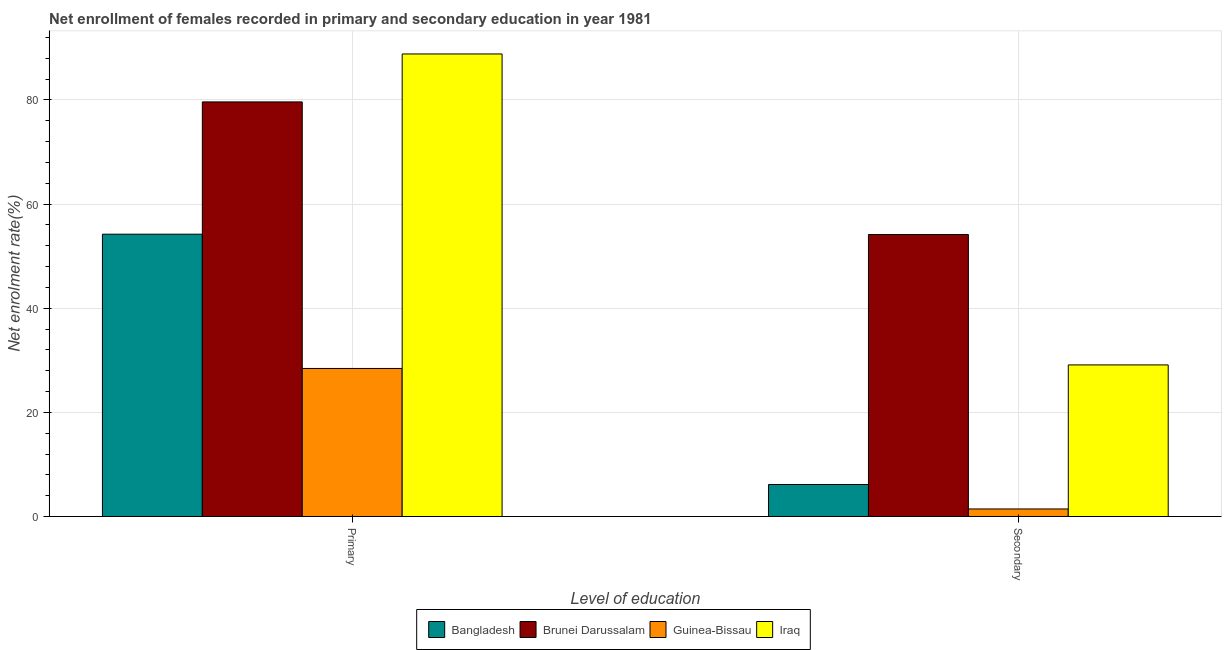How many groups of bars are there?
Provide a succinct answer. 2. Are the number of bars per tick equal to the number of legend labels?
Your response must be concise. Yes. Are the number of bars on each tick of the X-axis equal?
Your answer should be compact. Yes. How many bars are there on the 2nd tick from the left?
Provide a succinct answer. 4. What is the label of the 1st group of bars from the left?
Offer a very short reply. Primary. What is the enrollment rate in primary education in Guinea-Bissau?
Your answer should be compact. 28.43. Across all countries, what is the maximum enrollment rate in primary education?
Your answer should be very brief. 88.82. Across all countries, what is the minimum enrollment rate in secondary education?
Your response must be concise. 1.45. In which country was the enrollment rate in secondary education maximum?
Your answer should be compact. Brunei Darussalam. In which country was the enrollment rate in secondary education minimum?
Give a very brief answer. Guinea-Bissau. What is the total enrollment rate in secondary education in the graph?
Your answer should be very brief. 90.86. What is the difference between the enrollment rate in secondary education in Bangladesh and that in Guinea-Bissau?
Provide a succinct answer. 4.7. What is the difference between the enrollment rate in secondary education in Bangladesh and the enrollment rate in primary education in Iraq?
Your answer should be very brief. -82.67. What is the average enrollment rate in primary education per country?
Provide a succinct answer. 62.77. What is the difference between the enrollment rate in secondary education and enrollment rate in primary education in Bangladesh?
Provide a succinct answer. -48.06. What is the ratio of the enrollment rate in secondary education in Guinea-Bissau to that in Brunei Darussalam?
Offer a very short reply. 0.03. Is the enrollment rate in primary education in Iraq less than that in Guinea-Bissau?
Keep it short and to the point. No. In how many countries, is the enrollment rate in primary education greater than the average enrollment rate in primary education taken over all countries?
Keep it short and to the point. 2. What does the 1st bar from the right in Secondary represents?
Give a very brief answer. Iraq. How many bars are there?
Provide a short and direct response. 8. Are all the bars in the graph horizontal?
Offer a very short reply. No. What is the difference between two consecutive major ticks on the Y-axis?
Offer a very short reply. 20. Are the values on the major ticks of Y-axis written in scientific E-notation?
Make the answer very short. No. Does the graph contain any zero values?
Offer a very short reply. No. Where does the legend appear in the graph?
Offer a very short reply. Bottom center. How many legend labels are there?
Keep it short and to the point. 4. How are the legend labels stacked?
Your response must be concise. Horizontal. What is the title of the graph?
Make the answer very short. Net enrollment of females recorded in primary and secondary education in year 1981. What is the label or title of the X-axis?
Provide a short and direct response. Level of education. What is the label or title of the Y-axis?
Keep it short and to the point. Net enrolment rate(%). What is the Net enrolment rate(%) in Bangladesh in Primary?
Your answer should be compact. 54.21. What is the Net enrolment rate(%) of Brunei Darussalam in Primary?
Provide a short and direct response. 79.61. What is the Net enrolment rate(%) of Guinea-Bissau in Primary?
Provide a succinct answer. 28.43. What is the Net enrolment rate(%) in Iraq in Primary?
Your response must be concise. 88.82. What is the Net enrolment rate(%) in Bangladesh in Secondary?
Provide a short and direct response. 6.15. What is the Net enrolment rate(%) in Brunei Darussalam in Secondary?
Your answer should be compact. 54.15. What is the Net enrolment rate(%) in Guinea-Bissau in Secondary?
Your answer should be compact. 1.45. What is the Net enrolment rate(%) in Iraq in Secondary?
Your answer should be very brief. 29.11. Across all Level of education, what is the maximum Net enrolment rate(%) in Bangladesh?
Make the answer very short. 54.21. Across all Level of education, what is the maximum Net enrolment rate(%) in Brunei Darussalam?
Your response must be concise. 79.61. Across all Level of education, what is the maximum Net enrolment rate(%) in Guinea-Bissau?
Provide a short and direct response. 28.43. Across all Level of education, what is the maximum Net enrolment rate(%) of Iraq?
Your answer should be very brief. 88.82. Across all Level of education, what is the minimum Net enrolment rate(%) in Bangladesh?
Keep it short and to the point. 6.15. Across all Level of education, what is the minimum Net enrolment rate(%) in Brunei Darussalam?
Offer a terse response. 54.15. Across all Level of education, what is the minimum Net enrolment rate(%) of Guinea-Bissau?
Make the answer very short. 1.45. Across all Level of education, what is the minimum Net enrolment rate(%) in Iraq?
Give a very brief answer. 29.11. What is the total Net enrolment rate(%) of Bangladesh in the graph?
Make the answer very short. 60.36. What is the total Net enrolment rate(%) in Brunei Darussalam in the graph?
Offer a very short reply. 133.76. What is the total Net enrolment rate(%) in Guinea-Bissau in the graph?
Your answer should be compact. 29.88. What is the total Net enrolment rate(%) of Iraq in the graph?
Offer a very short reply. 117.93. What is the difference between the Net enrolment rate(%) of Bangladesh in Primary and that in Secondary?
Provide a short and direct response. 48.06. What is the difference between the Net enrolment rate(%) of Brunei Darussalam in Primary and that in Secondary?
Your answer should be compact. 25.46. What is the difference between the Net enrolment rate(%) in Guinea-Bissau in Primary and that in Secondary?
Keep it short and to the point. 26.98. What is the difference between the Net enrolment rate(%) of Iraq in Primary and that in Secondary?
Offer a terse response. 59.71. What is the difference between the Net enrolment rate(%) in Bangladesh in Primary and the Net enrolment rate(%) in Brunei Darussalam in Secondary?
Your response must be concise. 0.06. What is the difference between the Net enrolment rate(%) of Bangladesh in Primary and the Net enrolment rate(%) of Guinea-Bissau in Secondary?
Your answer should be very brief. 52.76. What is the difference between the Net enrolment rate(%) of Bangladesh in Primary and the Net enrolment rate(%) of Iraq in Secondary?
Provide a short and direct response. 25.1. What is the difference between the Net enrolment rate(%) in Brunei Darussalam in Primary and the Net enrolment rate(%) in Guinea-Bissau in Secondary?
Ensure brevity in your answer.  78.16. What is the difference between the Net enrolment rate(%) in Brunei Darussalam in Primary and the Net enrolment rate(%) in Iraq in Secondary?
Offer a terse response. 50.5. What is the difference between the Net enrolment rate(%) of Guinea-Bissau in Primary and the Net enrolment rate(%) of Iraq in Secondary?
Give a very brief answer. -0.68. What is the average Net enrolment rate(%) of Bangladesh per Level of education?
Provide a short and direct response. 30.18. What is the average Net enrolment rate(%) of Brunei Darussalam per Level of education?
Provide a succinct answer. 66.88. What is the average Net enrolment rate(%) of Guinea-Bissau per Level of education?
Provide a short and direct response. 14.94. What is the average Net enrolment rate(%) in Iraq per Level of education?
Keep it short and to the point. 58.97. What is the difference between the Net enrolment rate(%) in Bangladesh and Net enrolment rate(%) in Brunei Darussalam in Primary?
Offer a very short reply. -25.4. What is the difference between the Net enrolment rate(%) in Bangladesh and Net enrolment rate(%) in Guinea-Bissau in Primary?
Provide a succinct answer. 25.78. What is the difference between the Net enrolment rate(%) in Bangladesh and Net enrolment rate(%) in Iraq in Primary?
Your response must be concise. -34.61. What is the difference between the Net enrolment rate(%) in Brunei Darussalam and Net enrolment rate(%) in Guinea-Bissau in Primary?
Your response must be concise. 51.18. What is the difference between the Net enrolment rate(%) of Brunei Darussalam and Net enrolment rate(%) of Iraq in Primary?
Your answer should be very brief. -9.21. What is the difference between the Net enrolment rate(%) of Guinea-Bissau and Net enrolment rate(%) of Iraq in Primary?
Your answer should be very brief. -60.39. What is the difference between the Net enrolment rate(%) of Bangladesh and Net enrolment rate(%) of Brunei Darussalam in Secondary?
Give a very brief answer. -48. What is the difference between the Net enrolment rate(%) of Bangladesh and Net enrolment rate(%) of Guinea-Bissau in Secondary?
Offer a terse response. 4.7. What is the difference between the Net enrolment rate(%) in Bangladesh and Net enrolment rate(%) in Iraq in Secondary?
Keep it short and to the point. -22.96. What is the difference between the Net enrolment rate(%) in Brunei Darussalam and Net enrolment rate(%) in Guinea-Bissau in Secondary?
Make the answer very short. 52.7. What is the difference between the Net enrolment rate(%) in Brunei Darussalam and Net enrolment rate(%) in Iraq in Secondary?
Your answer should be compact. 25.04. What is the difference between the Net enrolment rate(%) in Guinea-Bissau and Net enrolment rate(%) in Iraq in Secondary?
Keep it short and to the point. -27.66. What is the ratio of the Net enrolment rate(%) in Bangladesh in Primary to that in Secondary?
Keep it short and to the point. 8.82. What is the ratio of the Net enrolment rate(%) in Brunei Darussalam in Primary to that in Secondary?
Keep it short and to the point. 1.47. What is the ratio of the Net enrolment rate(%) in Guinea-Bissau in Primary to that in Secondary?
Ensure brevity in your answer.  19.58. What is the ratio of the Net enrolment rate(%) of Iraq in Primary to that in Secondary?
Provide a short and direct response. 3.05. What is the difference between the highest and the second highest Net enrolment rate(%) of Bangladesh?
Ensure brevity in your answer.  48.06. What is the difference between the highest and the second highest Net enrolment rate(%) of Brunei Darussalam?
Make the answer very short. 25.46. What is the difference between the highest and the second highest Net enrolment rate(%) of Guinea-Bissau?
Make the answer very short. 26.98. What is the difference between the highest and the second highest Net enrolment rate(%) in Iraq?
Keep it short and to the point. 59.71. What is the difference between the highest and the lowest Net enrolment rate(%) in Bangladesh?
Ensure brevity in your answer.  48.06. What is the difference between the highest and the lowest Net enrolment rate(%) in Brunei Darussalam?
Give a very brief answer. 25.46. What is the difference between the highest and the lowest Net enrolment rate(%) in Guinea-Bissau?
Your response must be concise. 26.98. What is the difference between the highest and the lowest Net enrolment rate(%) of Iraq?
Offer a terse response. 59.71. 